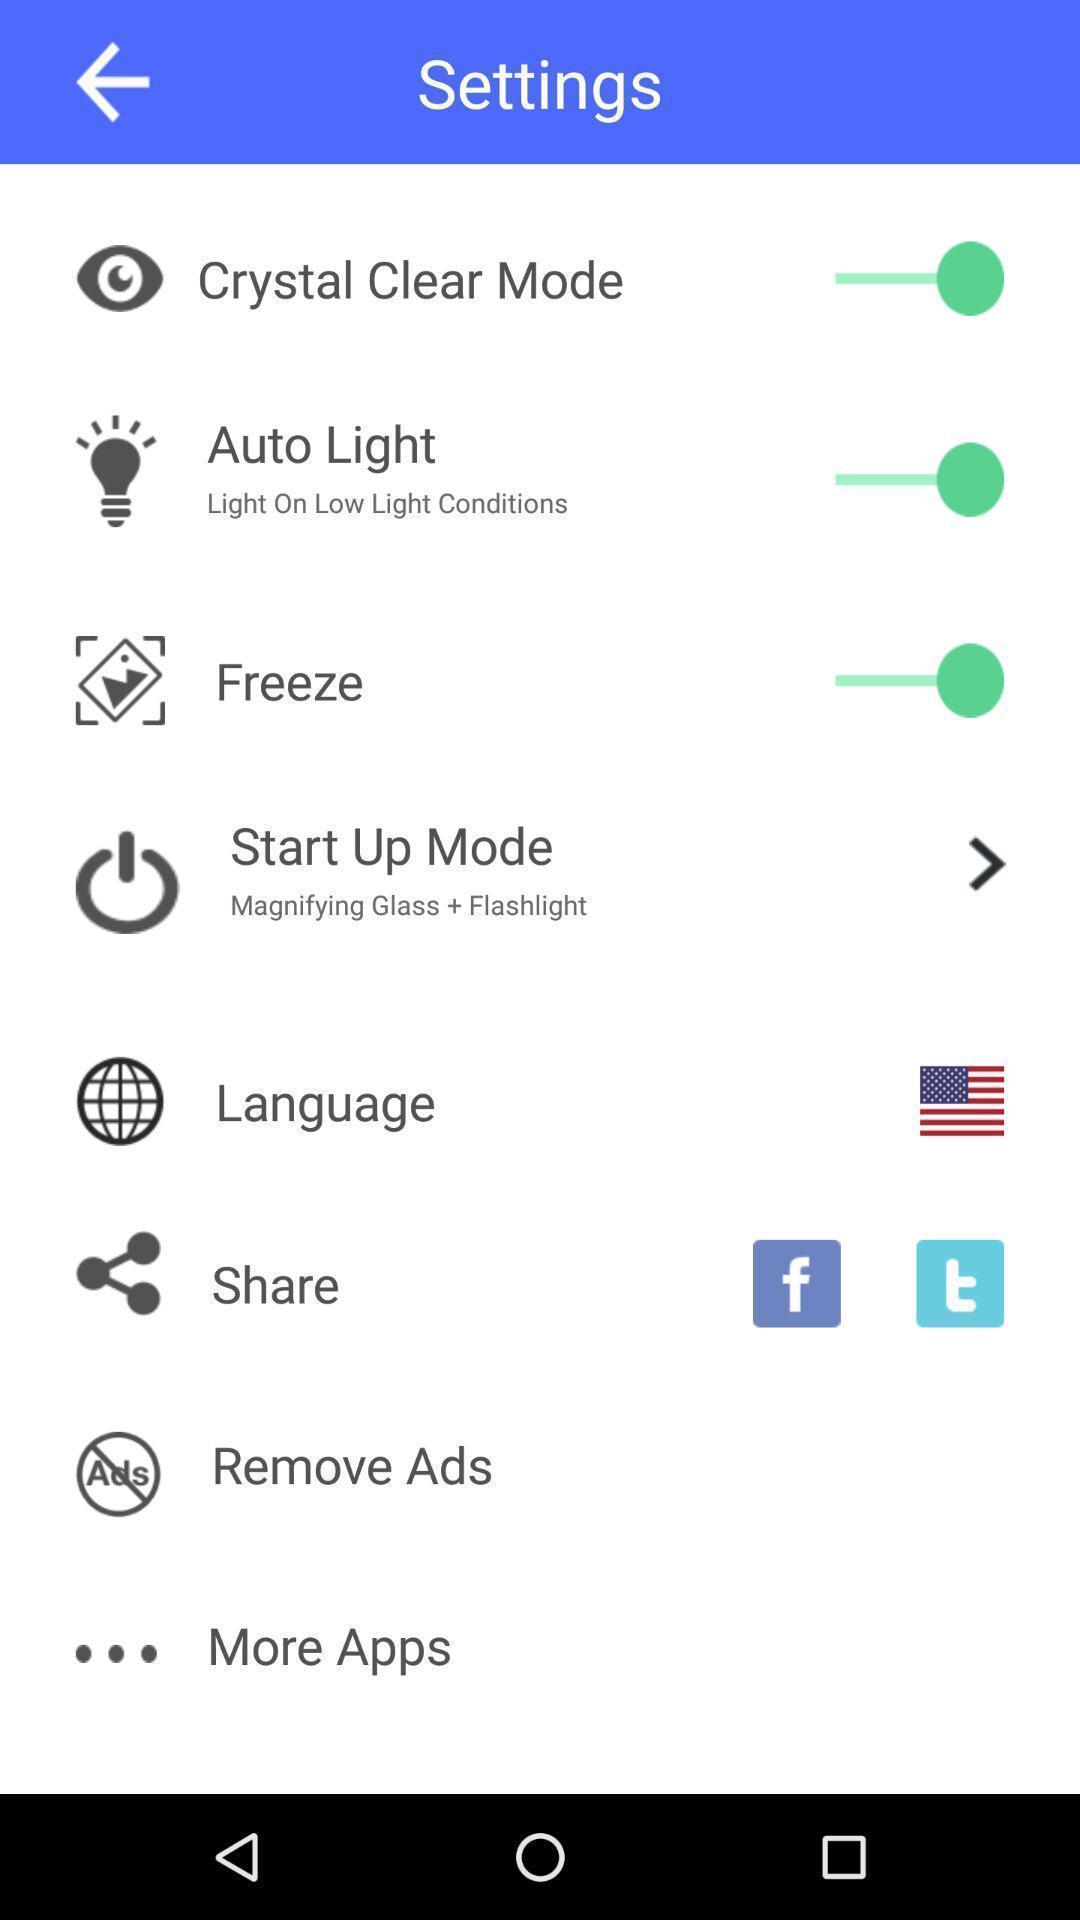What is the overall content of this screenshot? Settings page. 